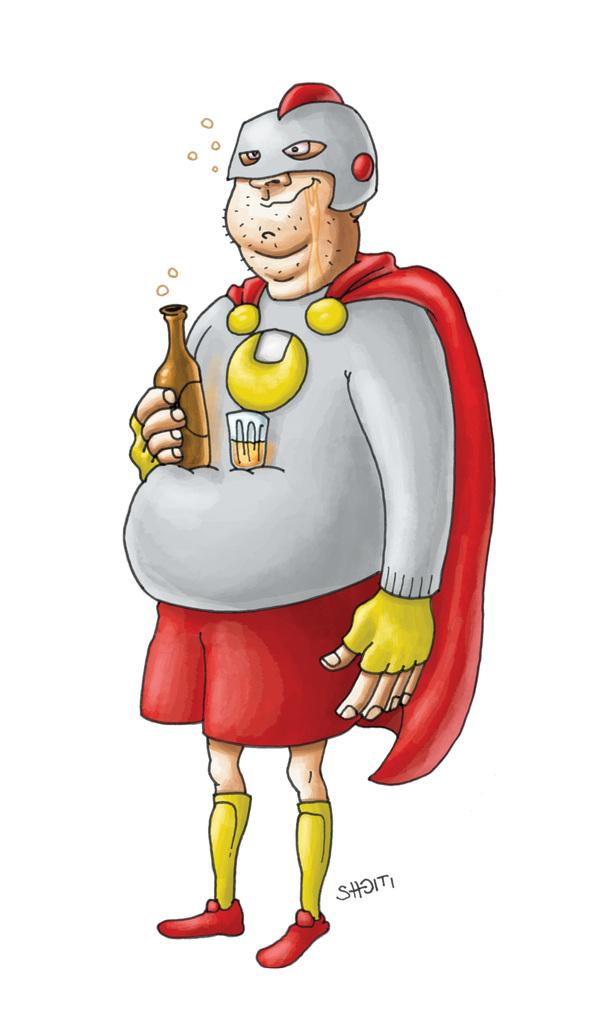Who or what is the main subject in the image? There is a person in the image. What is the person holding in the image? The person is holding a bottle. Where is the person and the bottle located in the image? The person and the bottle are in the center of the image. Can you tell me how many turkeys are present in the image? There are no turkeys present in the image; it features a person holding a bottle. How does the person touch the bottle in the image? The image does not show the person touching the bottle, only holding it. 